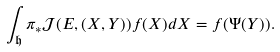Convert formula to latex. <formula><loc_0><loc_0><loc_500><loc_500>\int _ { \mathfrak { h } } \pi _ { * } \mathcal { J } ( E , ( X , Y ) ) f ( X ) d X = f ( \Psi ( Y ) ) .</formula> 